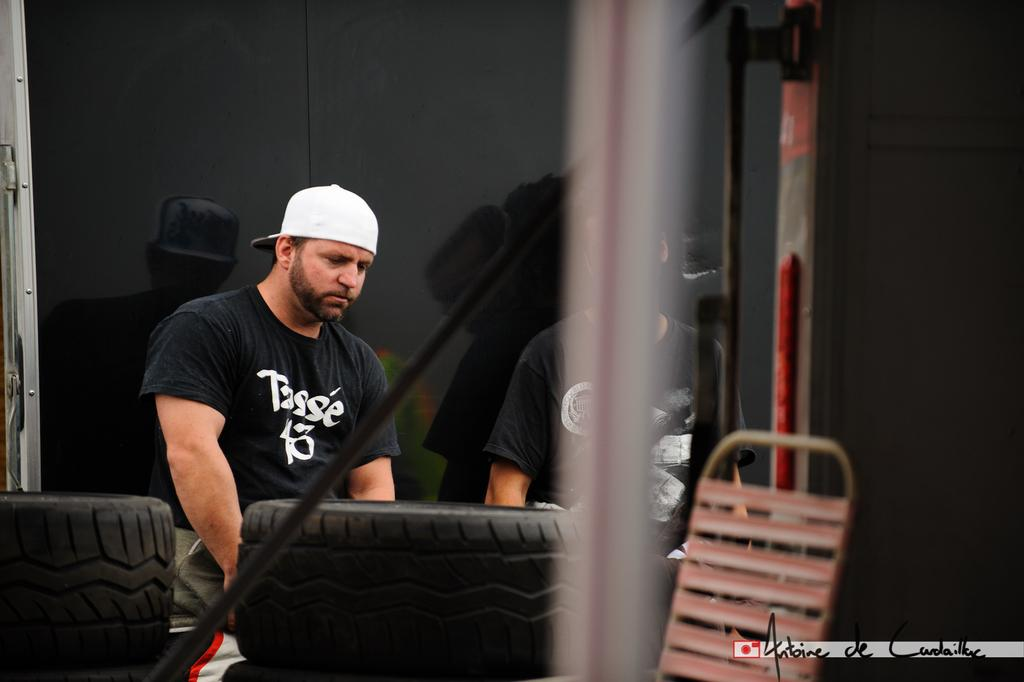Who is the main subject in the image? There is a person in the center of the image. What is the person wearing on their head? The person is wearing a cap. What can be seen in the background of the image? There are tiers in the image. What is the person sitting on in the image? There is a chair in the image. How many frogs are sitting on the wall in the image? There are no frogs or walls present in the image. What day of the week is depicted in the image? The image does not depict a specific day of the week. 